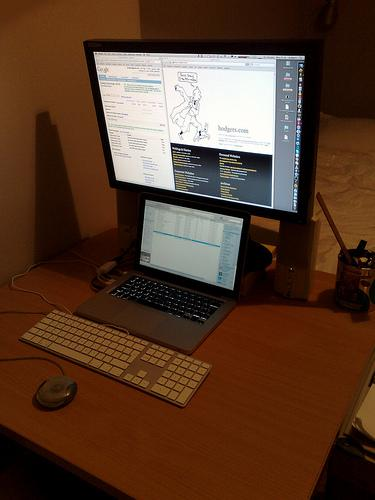Question: how many computers are there?
Choices:
A. One.
B. Two.
C. Three.
D. Four.
Answer with the letter. Answer: B 